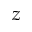Convert formula to latex. <formula><loc_0><loc_0><loc_500><loc_500>z</formula> 